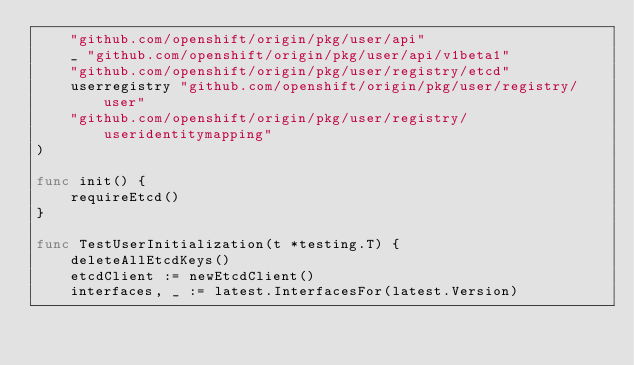Convert code to text. <code><loc_0><loc_0><loc_500><loc_500><_Go_>	"github.com/openshift/origin/pkg/user/api"
	_ "github.com/openshift/origin/pkg/user/api/v1beta1"
	"github.com/openshift/origin/pkg/user/registry/etcd"
	userregistry "github.com/openshift/origin/pkg/user/registry/user"
	"github.com/openshift/origin/pkg/user/registry/useridentitymapping"
)

func init() {
	requireEtcd()
}

func TestUserInitialization(t *testing.T) {
	deleteAllEtcdKeys()
	etcdClient := newEtcdClient()
	interfaces, _ := latest.InterfacesFor(latest.Version)</code> 